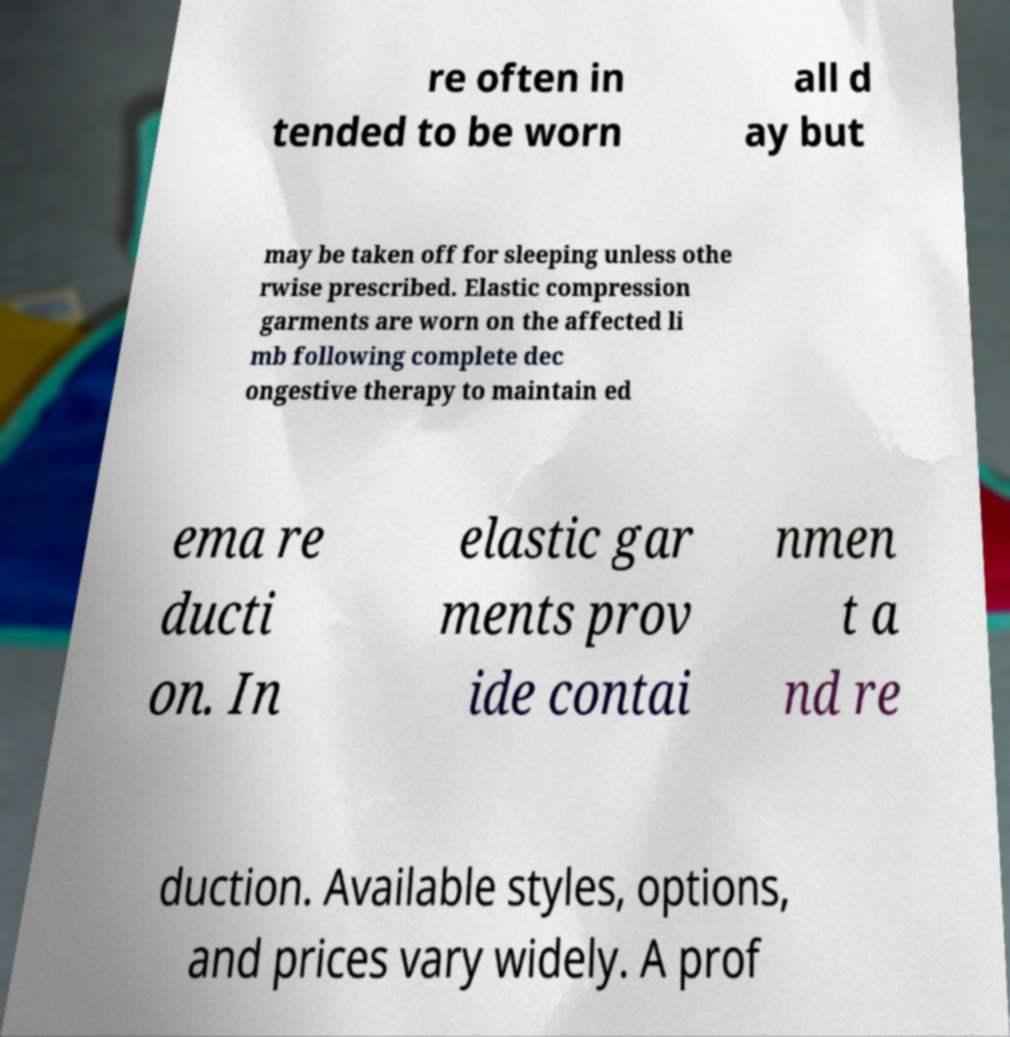Please identify and transcribe the text found in this image. re often in tended to be worn all d ay but may be taken off for sleeping unless othe rwise prescribed. Elastic compression garments are worn on the affected li mb following complete dec ongestive therapy to maintain ed ema re ducti on. In elastic gar ments prov ide contai nmen t a nd re duction. Available styles, options, and prices vary widely. A prof 